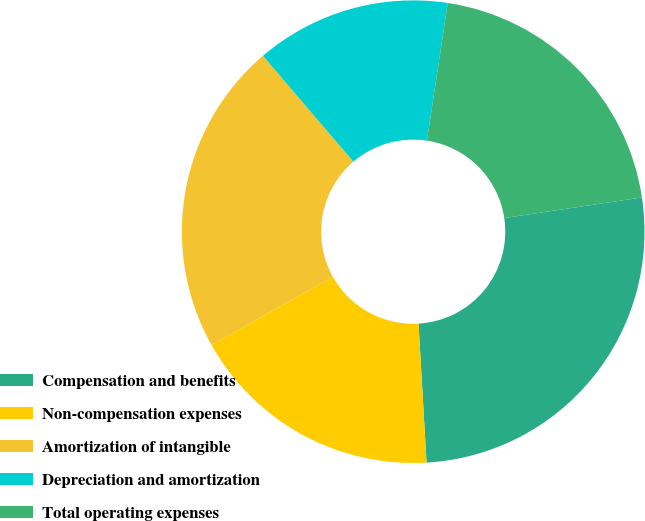Convert chart to OTSL. <chart><loc_0><loc_0><loc_500><loc_500><pie_chart><fcel>Compensation and benefits<fcel>Non-compensation expenses<fcel>Amortization of intangible<fcel>Depreciation and amortization<fcel>Total operating expenses<nl><fcel>26.45%<fcel>17.77%<fcel>21.9%<fcel>13.64%<fcel>20.25%<nl></chart> 